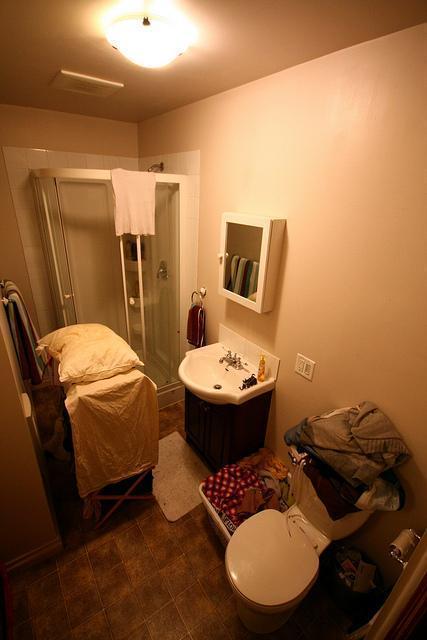How many umbrellas are in this scene?
Give a very brief answer. 0. 